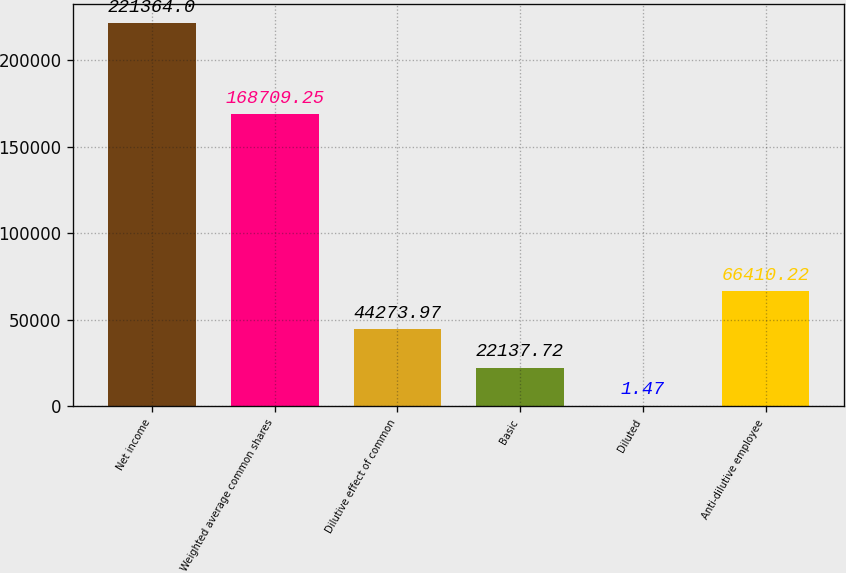Convert chart. <chart><loc_0><loc_0><loc_500><loc_500><bar_chart><fcel>Net income<fcel>Weighted average common shares<fcel>Dilutive effect of common<fcel>Basic<fcel>Diluted<fcel>Anti-dilutive employee<nl><fcel>221364<fcel>168709<fcel>44274<fcel>22137.7<fcel>1.47<fcel>66410.2<nl></chart> 